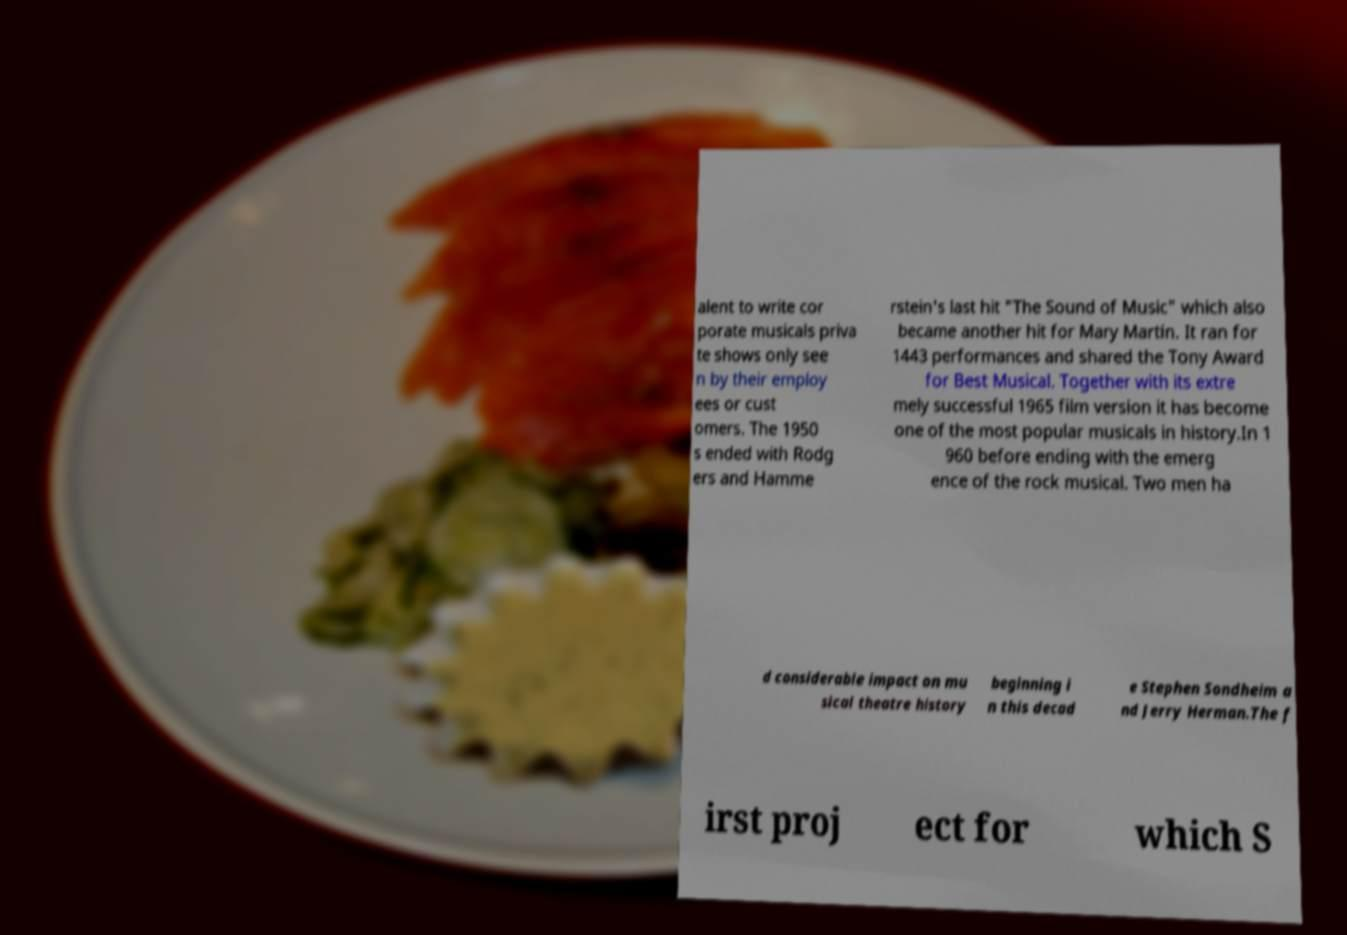What messages or text are displayed in this image? I need them in a readable, typed format. alent to write cor porate musicals priva te shows only see n by their employ ees or cust omers. The 1950 s ended with Rodg ers and Hamme rstein's last hit "The Sound of Music" which also became another hit for Mary Martin. It ran for 1443 performances and shared the Tony Award for Best Musical. Together with its extre mely successful 1965 film version it has become one of the most popular musicals in history.In 1 960 before ending with the emerg ence of the rock musical. Two men ha d considerable impact on mu sical theatre history beginning i n this decad e Stephen Sondheim a nd Jerry Herman.The f irst proj ect for which S 